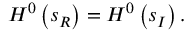Convert formula to latex. <formula><loc_0><loc_0><loc_500><loc_500>H ^ { 0 } \left ( s _ { R } \right ) = H ^ { 0 } \left ( s _ { I } \right ) .</formula> 